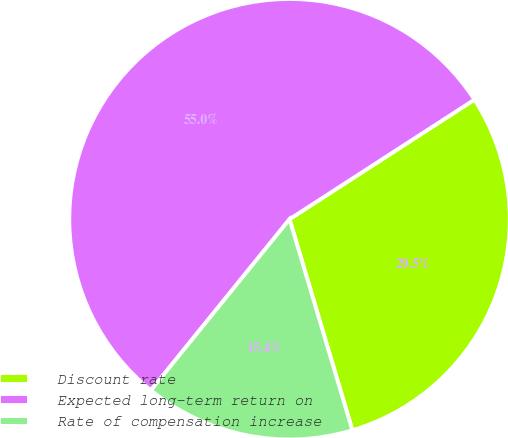Convert chart to OTSL. <chart><loc_0><loc_0><loc_500><loc_500><pie_chart><fcel>Discount rate<fcel>Expected long-term return on<fcel>Rate of compensation increase<nl><fcel>29.53%<fcel>55.03%<fcel>15.44%<nl></chart> 